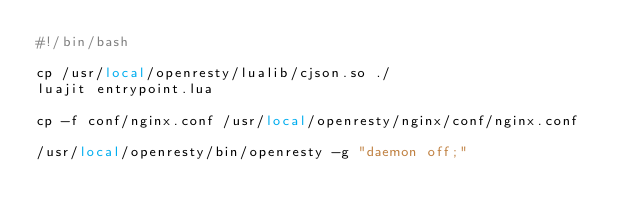<code> <loc_0><loc_0><loc_500><loc_500><_Bash_>#!/bin/bash

cp /usr/local/openresty/lualib/cjson.so ./
luajit entrypoint.lua

cp -f conf/nginx.conf /usr/local/openresty/nginx/conf/nginx.conf

/usr/local/openresty/bin/openresty -g "daemon off;"</code> 